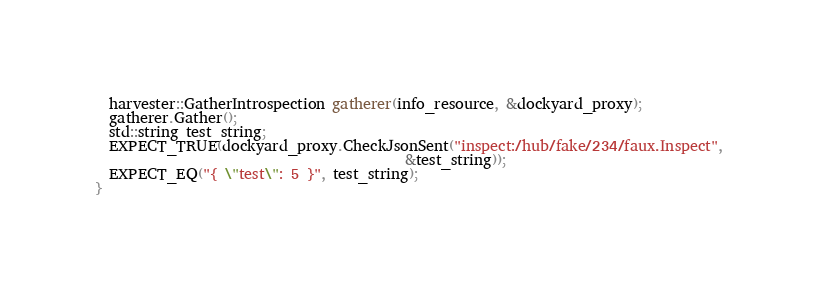<code> <loc_0><loc_0><loc_500><loc_500><_C++_>  harvester::GatherIntrospection gatherer(info_resource, &dockyard_proxy);
  gatherer.Gather();
  std::string test_string;
  EXPECT_TRUE(dockyard_proxy.CheckJsonSent("inspect:/hub/fake/234/faux.Inspect",
                                           &test_string));
  EXPECT_EQ("{ \"test\": 5 }", test_string);
}
</code> 